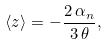Convert formula to latex. <formula><loc_0><loc_0><loc_500><loc_500>\langle z \rangle = - \frac { 2 \, \alpha _ { n } } { 3 \, \theta } ,</formula> 